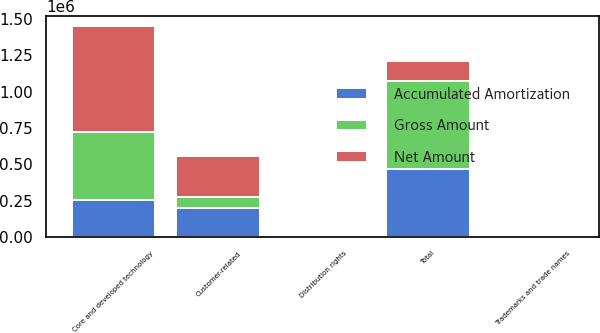Convert chart. <chart><loc_0><loc_0><loc_500><loc_500><stacked_bar_chart><ecel><fcel>Core and developed technology<fcel>Customer-related<fcel>Trademarks and trade names<fcel>Distribution rights<fcel>Total<nl><fcel>Net Amount<fcel>724883<fcel>278542<fcel>11700<fcel>5580<fcel>139271<nl><fcel>Accumulated Amortization<fcel>255460<fcel>200331<fcel>7571<fcel>5302<fcel>468664<nl><fcel>Gross Amount<fcel>469423<fcel>78211<fcel>4129<fcel>278<fcel>606349<nl></chart> 